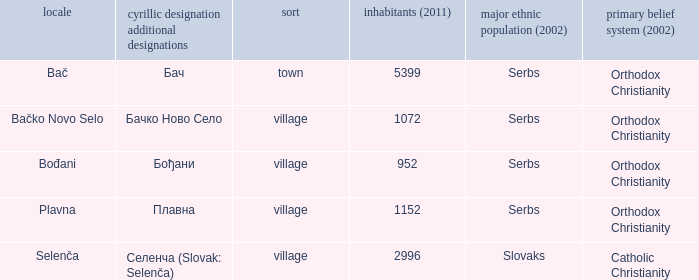What is the smallest population listed? 952.0. 